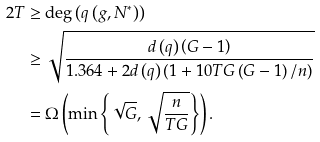Convert formula to latex. <formula><loc_0><loc_0><loc_500><loc_500>2 T & \geq \deg \left ( q \left ( g , N ^ { \ast } \right ) \right ) \\ & \geq \sqrt { \frac { d \left ( q \right ) \left ( G - 1 \right ) } { 1 . 3 6 4 + 2 d \left ( q \right ) \left ( 1 + 1 0 T G \left ( G - 1 \right ) / n \right ) } } \\ & = \Omega \left ( \min \left \{ \sqrt { G } , \sqrt { \frac { n } { T G } } \right \} \right ) .</formula> 